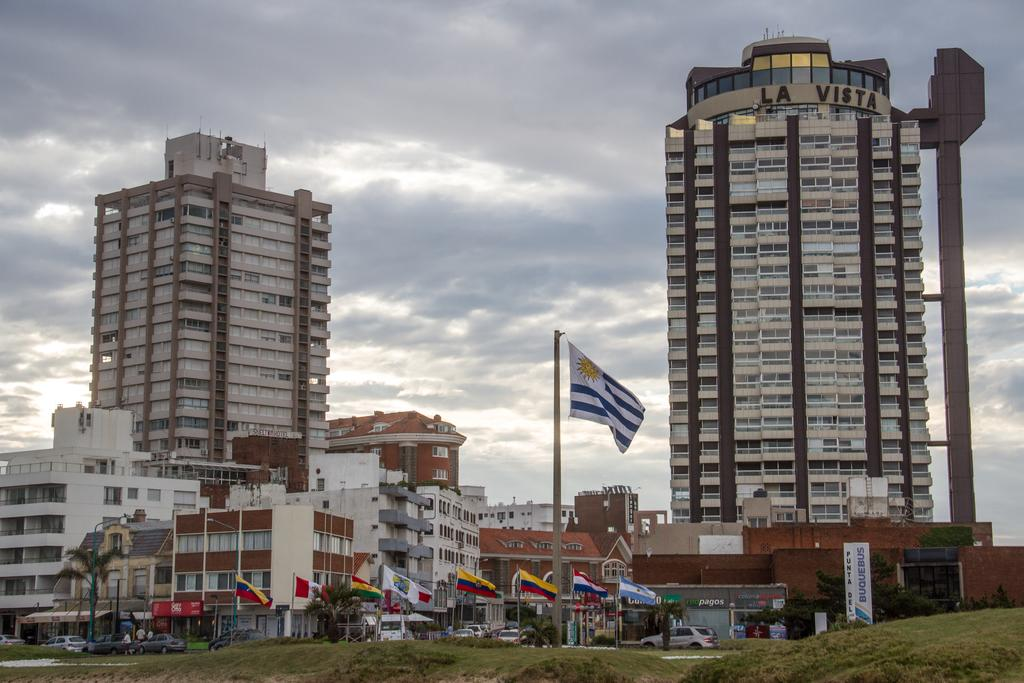What type of structures are visible in the image? There are buildings and homes in the image. What can be seen on the ground in the image? There are flags on the ground in the image. What type of vehicles are present in the image? There are cars on the road in the image. What is visible at the top of the image? The sky is visible at the top of the image. What is the condition of the sky in the image? The sky is cloudy in the image. What type of crown is being worn by the person in the image? There is no person wearing a crown in the image; it features buildings, homes, flags, cars, and a cloudy sky. How many points does the person in the image have on their throat? There is no person present in the image, so it is not possible to determine the number of points on their throat. 